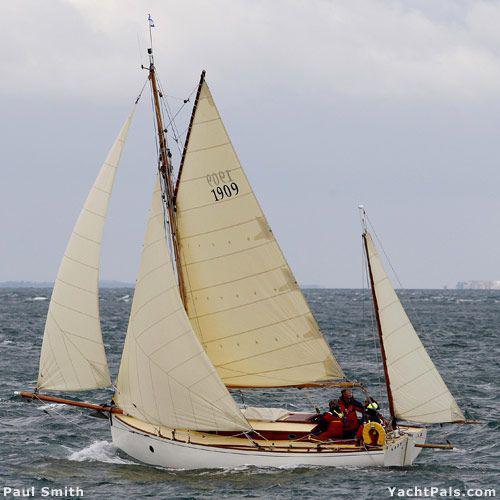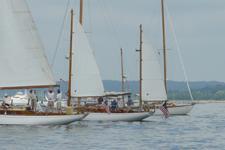The first image is the image on the left, the second image is the image on the right. Examine the images to the left and right. Is the description "There is just one sailboat in one of the images, but the other has at least three sailboats." accurate? Answer yes or no. Yes. The first image is the image on the left, the second image is the image on the right. Considering the images on both sides, is "In at least one image there is a white boat facing right sailing on the water." valid? Answer yes or no. No. 